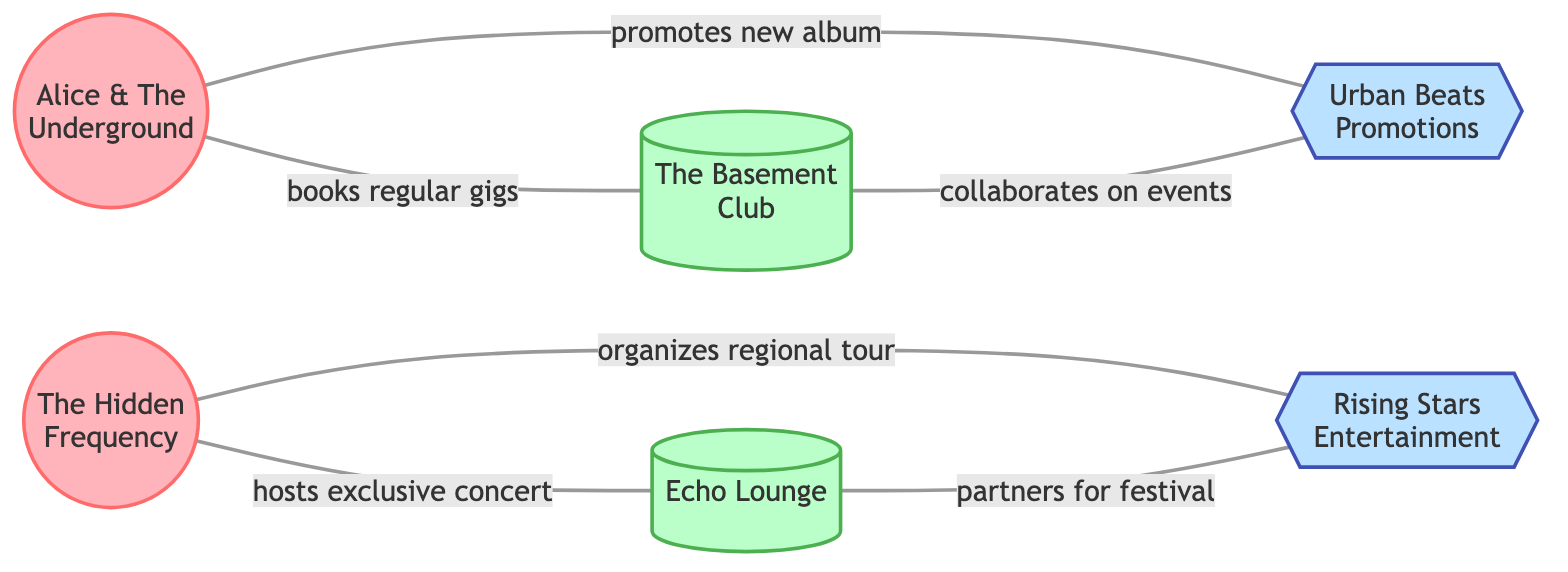What is the total number of nodes in the diagram? There are six nodes listed in the data; two are indie musicians, two are venues, and two are promoters. Counting each of them gives a total of 6.
Answer: 6 Which venue does Alice & The Underground book regular gigs at? Alice & The Underground is connected to The Basement Club with the relationship of "books regular gigs." Therefore, the venue is The Basement Club.
Answer: The Basement Club How many edges connect the node "The Hidden Frequency"? The Hidden Frequency has two edges connecting it: one to Echo Lounge and one to Rising Stars Entertainment. Therefore, it connects through 2 edges.
Answer: 2 What relationship exists between The Basement Club and Urban Beats Promotions? There is a direct connection where The Basement Club collaborates on events with Urban Beats Promotions. This relationship is clearly noted in the edges.
Answer: collaborates on events Which promoter organizes a regional tour for The Hidden Frequency? The edge indicates that The Hidden Frequency is organized by Rising Stars Entertainment for a regional tour. This direct connection makes it clear.
Answer: Rising Stars Entertainment How many collections of connections (edges) involve venues? The diagram has edges connecting to venues as follows: The Basement Club with one edge to Alice & The Underground and another to Urban Beats Promotions; Echo Lounge connects to The Hidden Frequency and to Rising Stars Entertainment. Thus, a total of 4 connections involve venues.
Answer: 4 What do both promoters collaborate on with their associated venues? Urban Beats Promotions collaborates on events with The Basement Club, while Rising Stars Entertainment partners for festivals with Echo Lounge. The relationship type is noted for both of them in the edges regarding their connection with the venues.
Answer: events and festivals Which indie musician hosts an exclusive concert and at which venue? The edge shows that The Hidden Frequency hosts an exclusive concert at Echo Lounge. This relationship directly connects the musician to the venue.
Answer: The Hidden Frequency, Echo Lounge 